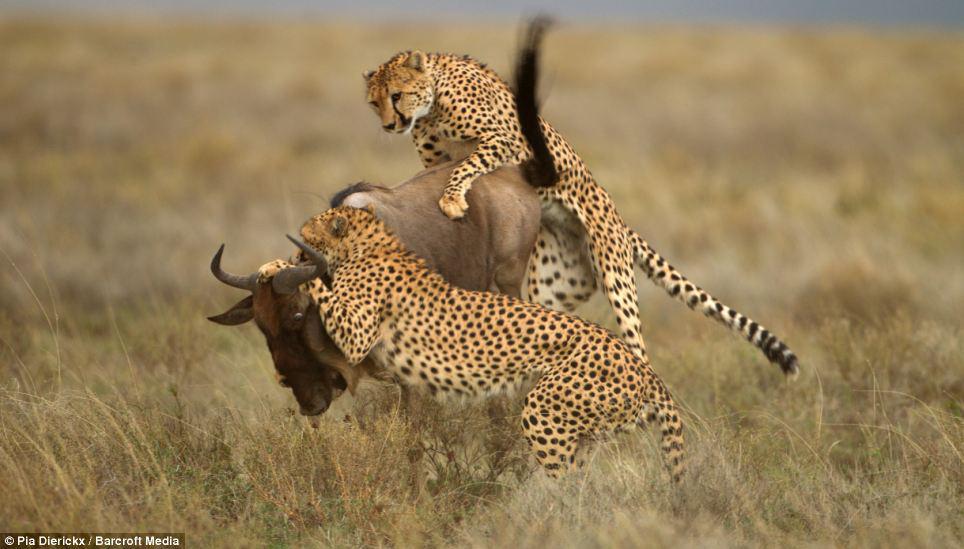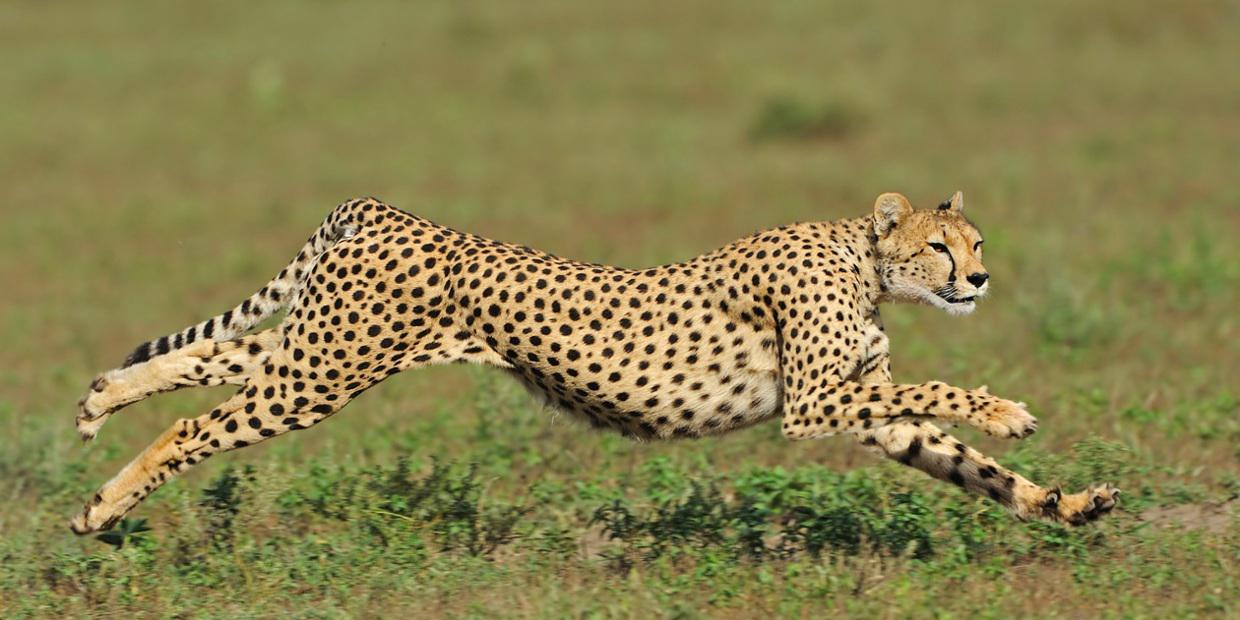The first image is the image on the left, the second image is the image on the right. Given the left and right images, does the statement "A wild cat with front paws extended is pouncing on visible prey in one image." hold true? Answer yes or no. Yes. The first image is the image on the left, the second image is the image on the right. Considering the images on both sides, is "There are exactly three animals in the image on the right." valid? Answer yes or no. No. 